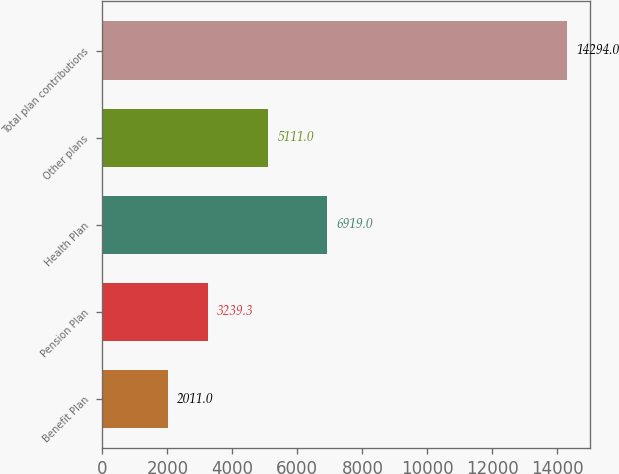Convert chart. <chart><loc_0><loc_0><loc_500><loc_500><bar_chart><fcel>Benefit Plan<fcel>Pension Plan<fcel>Health Plan<fcel>Other plans<fcel>Total plan contributions<nl><fcel>2011<fcel>3239.3<fcel>6919<fcel>5111<fcel>14294<nl></chart> 